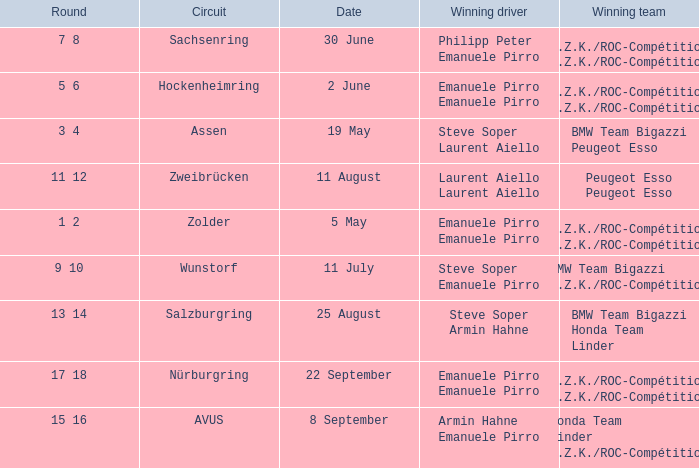Can you give me this table as a dict? {'header': ['Round', 'Circuit', 'Date', 'Winning driver', 'Winning team'], 'rows': [['7 8', 'Sachsenring', '30 June', 'Philipp Peter Emanuele Pirro', 'A.Z.K./ROC-Compétition A.Z.K./ROC-Compétition'], ['5 6', 'Hockenheimring', '2 June', 'Emanuele Pirro Emanuele Pirro', 'A.Z.K./ROC-Compétition A.Z.K./ROC-Compétition'], ['3 4', 'Assen', '19 May', 'Steve Soper Laurent Aiello', 'BMW Team Bigazzi Peugeot Esso'], ['11 12', 'Zweibrücken', '11 August', 'Laurent Aiello Laurent Aiello', 'Peugeot Esso Peugeot Esso'], ['1 2', 'Zolder', '5 May', 'Emanuele Pirro Emanuele Pirro', 'A.Z.K./ROC-Compétition A.Z.K./ROC-Compétition'], ['9 10', 'Wunstorf', '11 July', 'Steve Soper Emanuele Pirro', 'BMW Team Bigazzi A.Z.K./ROC-Compétition'], ['13 14', 'Salzburgring', '25 August', 'Steve Soper Armin Hahne', 'BMW Team Bigazzi Honda Team Linder'], ['17 18', 'Nürburgring', '22 September', 'Emanuele Pirro Emanuele Pirro', 'A.Z.K./ROC-Compétition A.Z.K./ROC-Compétition'], ['15 16', 'AVUS', '8 September', 'Armin Hahne Emanuele Pirro', 'Honda Team Linder A.Z.K./ROC-Compétition']]} Who is the winning driver of the race on 2 June with a.z.k./roc-compétition a.z.k./roc-compétition as the winning team? Emanuele Pirro Emanuele Pirro. 